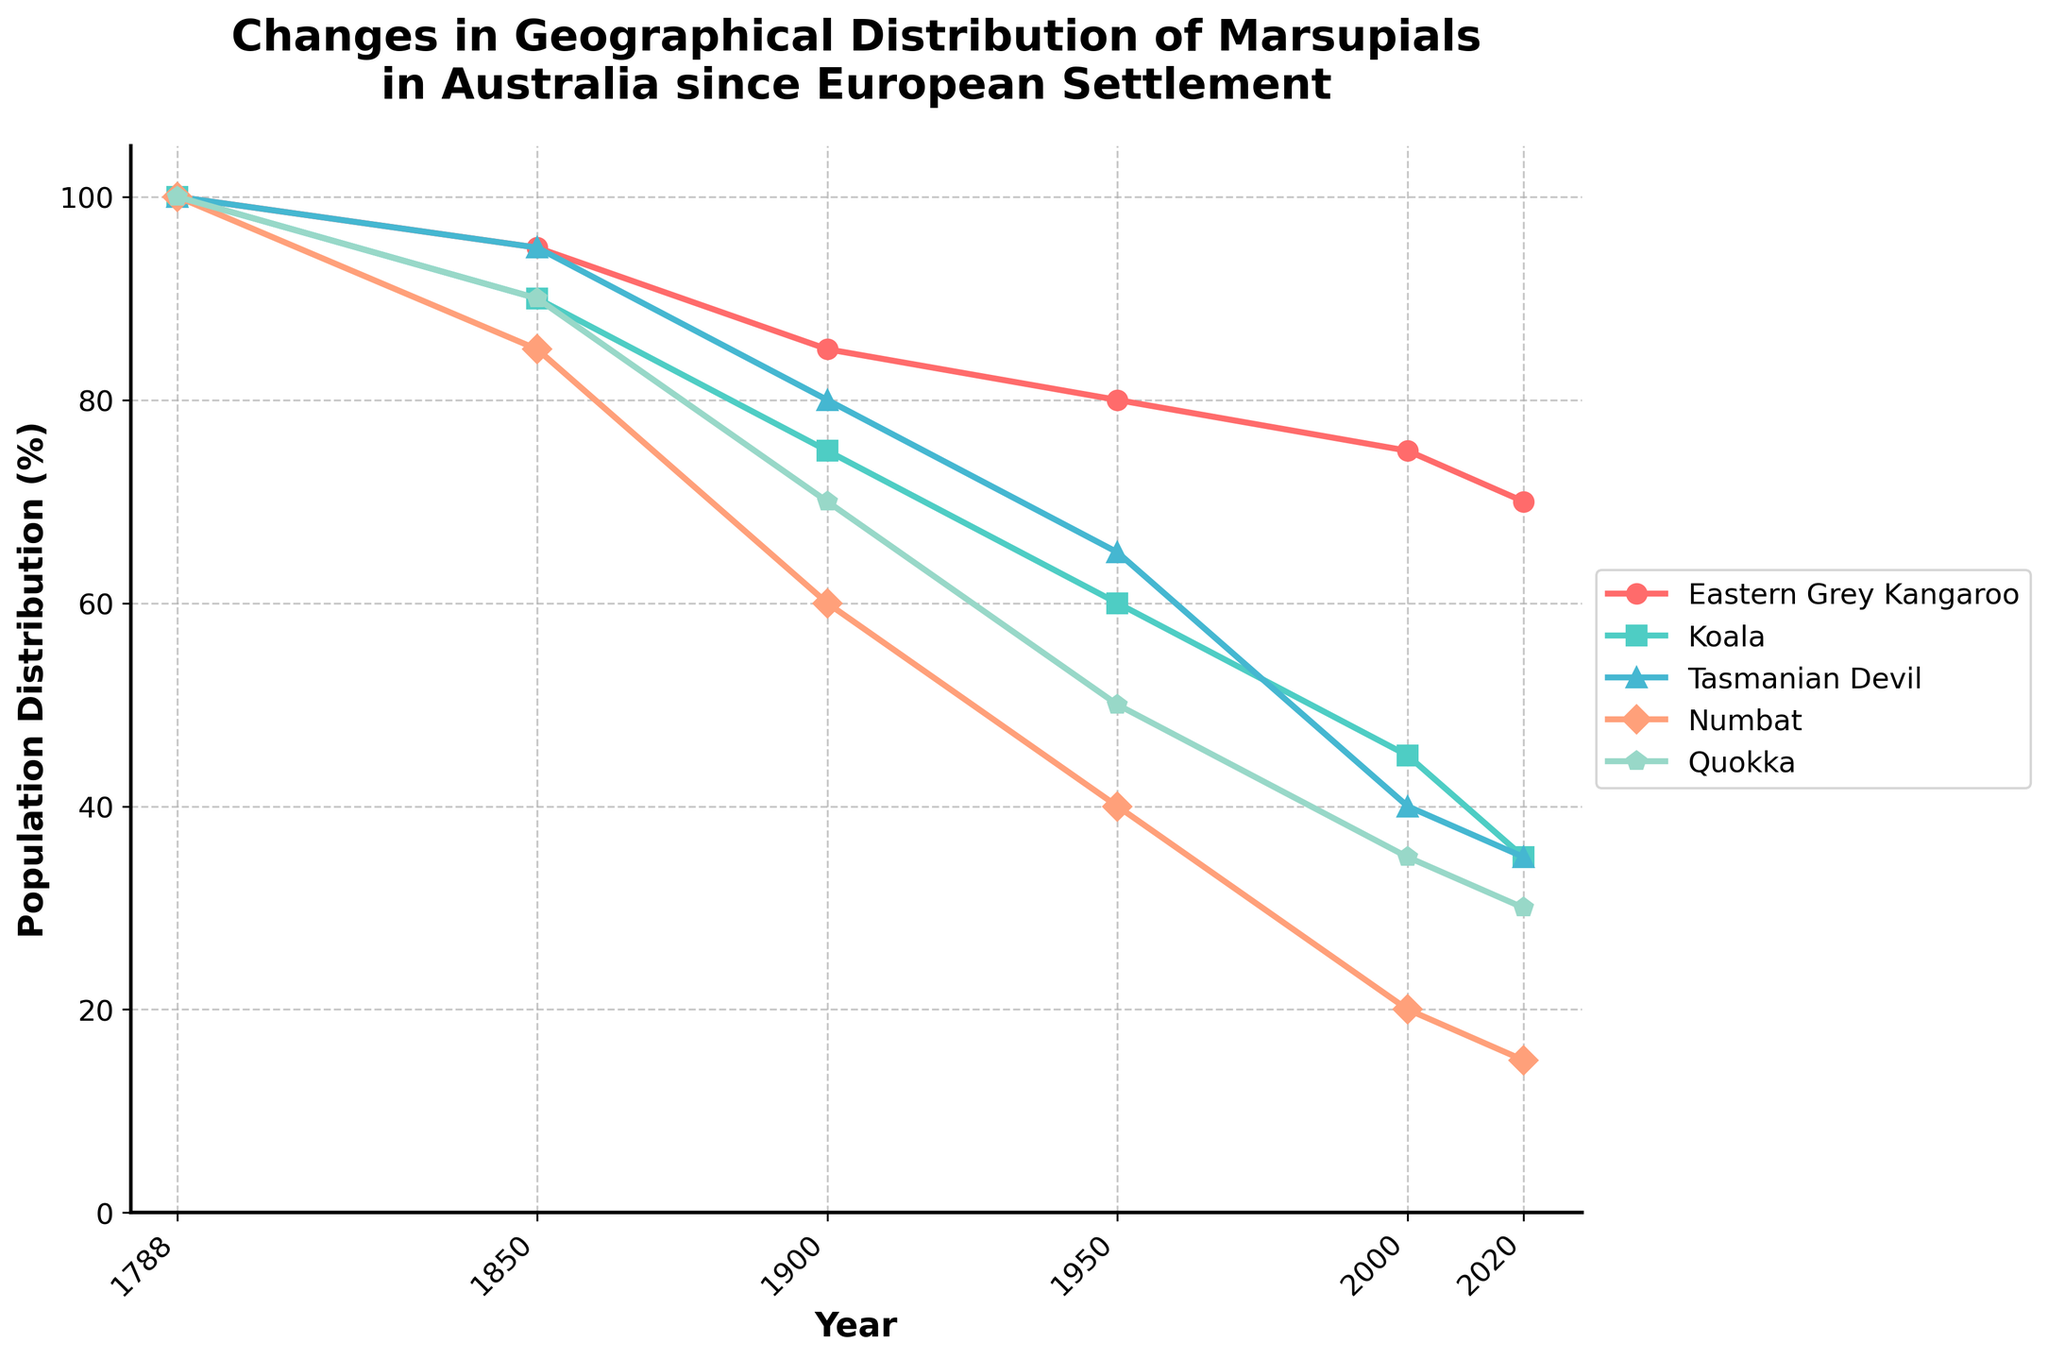What year did the Eastern Grey Kangaroo have the highest population distribution after 1788? By examining the plotted line for the Eastern Grey Kangaroo, we can see that its population distribution has been declining since 1788. The year following 1788 with the highest distribution is 1850.
Answer: 1850 Which marsupial's population distribution decreased the most between 1850 and 2020? To identify which marsupial saw the largest decrease, we subtract the 2020 value from the 1850 value for each animal: Eastern Grey Kangaroo (95-70=25), Koala (90-35=55), Tasmanian Devil (95-35=60), Numbat (85-15=70), Quokka (90-30=60). The Numbat shows the largest decrease.
Answer: Numbat How much did the population distribution of the Koala change between 1900 and 1950? By subtracting the 1950 value for the Koala (60) from the 1900 value (75), we find the change is 75 - 60 = 15.
Answer: 15 Which marsupial had the lowest population distribution in 2000? Observing the values in 2000, the Numbat has the lowest population distribution at 20.
Answer: Numbat What's the average percentage distribution of the Quokka population from 1788 to 2020? Averaging the six data points for the Quokka (100, 90, 70, 50, 35, 30): (100 + 90 + 70 + 50 + 35 + 30) / 6 = 62.5.
Answer: 62.5 How does the population distribution of the Tasmanian Devil in 2020 compare to its distribution in 1788? The Tasmanian Devil's population distribution declined from 100 in 1788 to 35 in 2020.
Answer: Declined Which marsupial showed relatively the smallest decline in distribution from 1788 to 2020? Calculating the decline for each: Eastern Grey Kangaroo (100-70=30), Koala (100-35=65), Tasmanian Devil (100-35=65), Numbat (100-15=85), Quokka (100-30=70). The Eastern Grey Kangaroo showed the smallest decline.
Answer: Eastern Grey Kangaroo During which period did the Numbat experience the steepest decline in population distribution? Observing the slope of the line for Numbat, the steepest decline is between 1900 and 1950 (80 to 40).
Answer: 1900 to 1950 